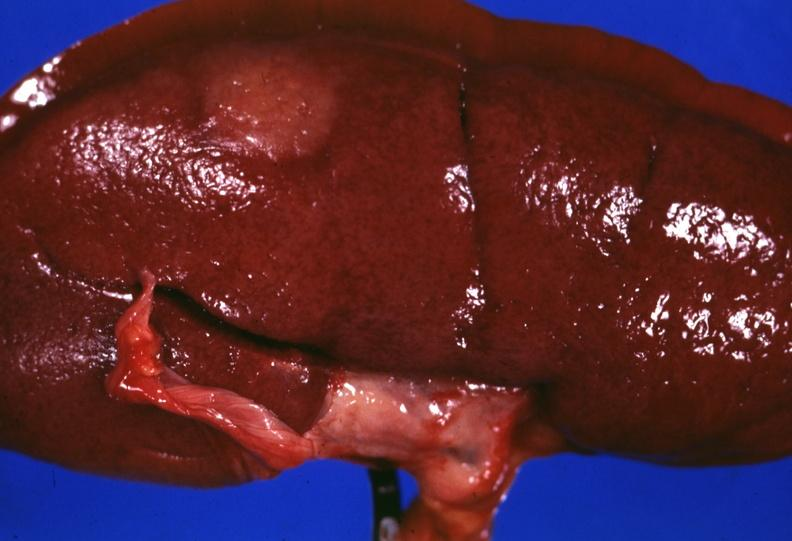does urinary show surface lesion capsule stripped unusual?
Answer the question using a single word or phrase. No 